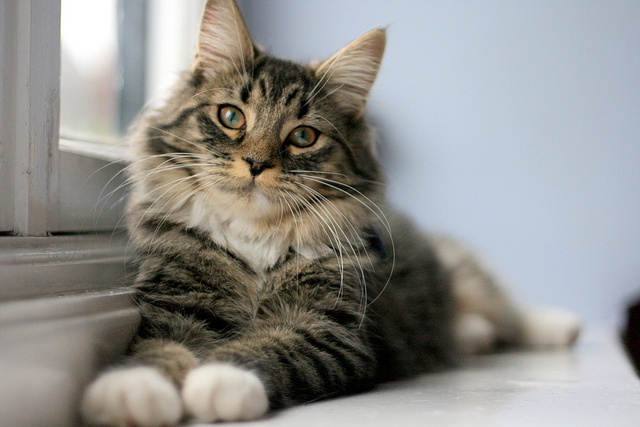Describe the objects in this image and their specific colors. I can see a cat in gray, black, and darkgray tones in this image. 